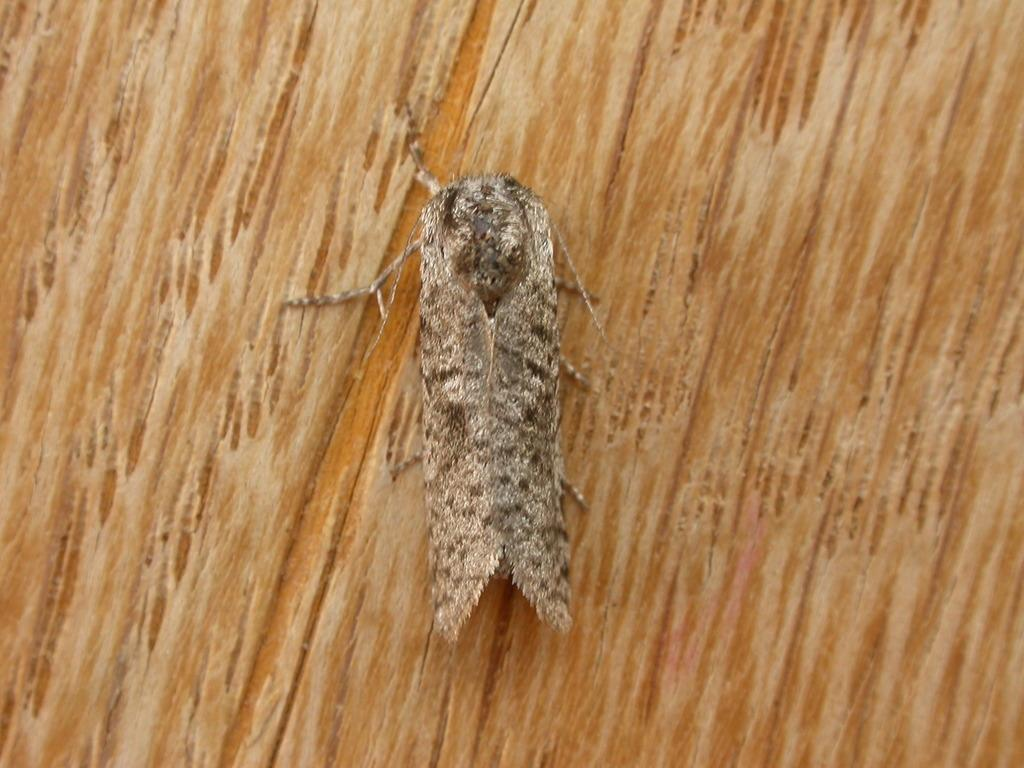What is the main subject of the image? There is an insect in the image. Where is the insect located in the image? The insect is in the center of the image. What type of surface is the insect on? The insect is on a wooden surface. What type of smell can be detected from the insect in the image? There is no indication of a smell in the image, as it is a visual representation of the insect on a wooden surface. 